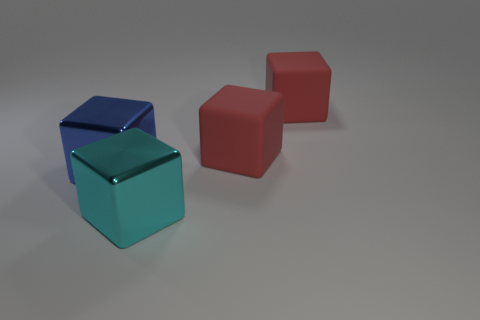Subtract 1 blocks. How many blocks are left? 3 Subtract all yellow blocks. Subtract all purple balls. How many blocks are left? 4 Add 3 large metal cubes. How many objects exist? 7 Subtract all large metal objects. Subtract all big blue shiny objects. How many objects are left? 1 Add 1 matte cubes. How many matte cubes are left? 3 Add 1 big blue objects. How many big blue objects exist? 2 Subtract 1 cyan cubes. How many objects are left? 3 